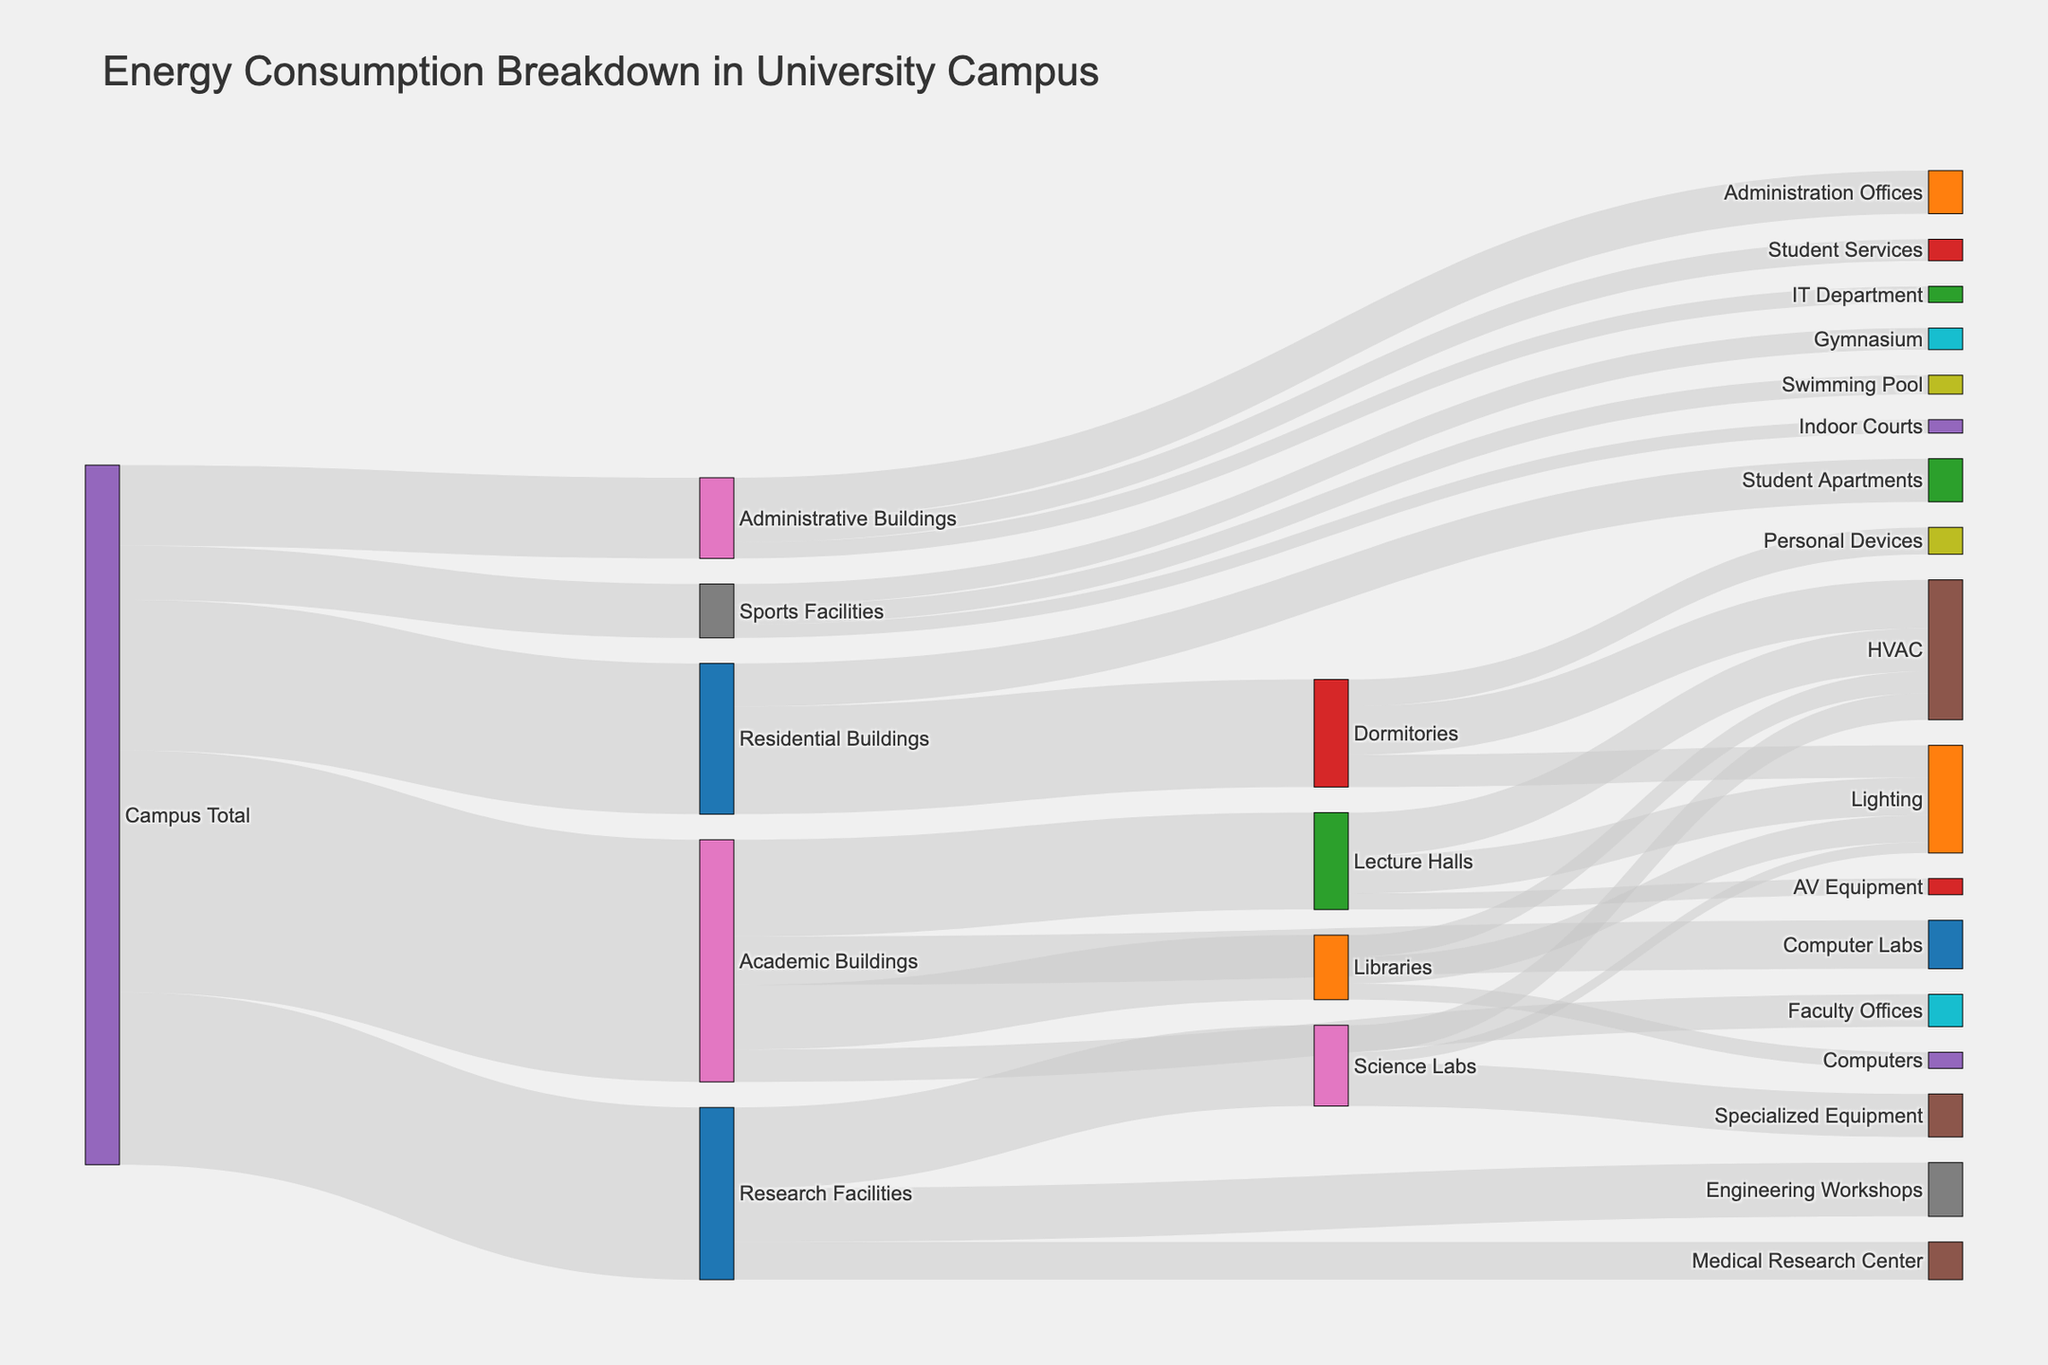What is the title of the Sankey diagram? The title of the diagram is displayed prominently at the top and it indicates the overall theme or subject of the diagram.
Answer: Energy Consumption Breakdown in University Campus Which building type consumes the most energy? To determine this, check the node connected to "Campus Total" with the highest value and labeled largest. In this case, "Academic Buildings" consumes 4500 units of energy.
Answer: Academic Buildings What is the total energy consumption of the Residential Buildings? Find the "Residential Buildings" node connected to "Campus Total" and note the value indicated. The Residential Buildings consume 2800 units of energy.
Answer: 2800 How much energy do Lecture Halls consume for lighting? Locate the node "Lecture Halls" and trace the link to "Lighting," noting the value. The energy consumption for lighting in Lecture Halls is 700 units.
Answer: 700 Compare the energy consumption between the IT Department and Student Services in Administrative Buildings. Find the nodes "IT Department" and "Student Services" under "Administrative Buildings" and compare their values. The IT Department consumes 300 units and Student Services consume 400 units.
Answer: IT Department: 300; Student Services: 400 Which facility within Research Facilities has the smallest energy consumption and how much is it? Locate the "Research Facilities" node and find the connected nodes. "Medical Research Center" has the smallest consumption of 700 units.
Answer: Medical Research Center: 700 What is the total energy consumption of HVAC systems in Academic Buildings? Identify and sum the energy values for HVAC systems in nodes under "Academic Buildings": Lecture Halls (800), Libraries (400), and Computer Labs and Faculty Offices are not explicit, so we sum: 800 + 400 = 1200 units.
Answer: 1200 Which type of energy usage in Sports Facilities consumes the most energy? Locate the "Sports Facilities" node and compare the values of connected nodes. The "Gymnasium" has the highest consumption with 400 units.
Answer: Gymnasium By how much does the energy consumption of Lecture Halls' HVAC system exceed that of Libraries' HVAC system? Find the values for HVAC systems in "Lecture Halls" (800 units) and "Libraries" (400 units) and subtract the latter from the former: 800 - 400 = 400 units.
Answer: 400 What is the percentage of energy consumption by computer labs in Academic Buildings relative to the total consumption of Academic Buildings? Find the value for "Computer Labs" (900 units) and the total for "Academic Buildings" (4500 units). Calculate (900 / 4500) * 100 = 20%.
Answer: 20% 